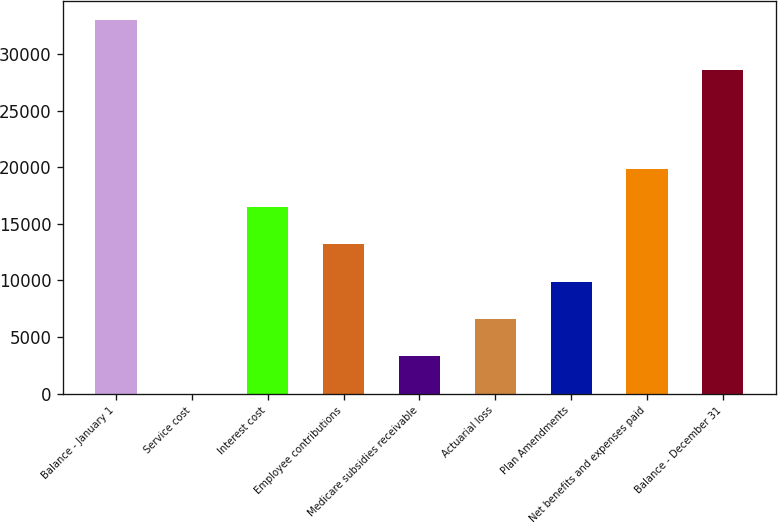<chart> <loc_0><loc_0><loc_500><loc_500><bar_chart><fcel>Balance - January 1<fcel>Service cost<fcel>Interest cost<fcel>Employee contributions<fcel>Medicare subsidies receivable<fcel>Actuarial loss<fcel>Plan Amendments<fcel>Net benefits and expenses paid<fcel>Balance - December 31<nl><fcel>33019<fcel>2<fcel>16510.5<fcel>13208.8<fcel>3303.7<fcel>6605.4<fcel>9907.1<fcel>19812.2<fcel>28614<nl></chart> 